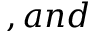<formula> <loc_0><loc_0><loc_500><loc_500>, a n d</formula> 